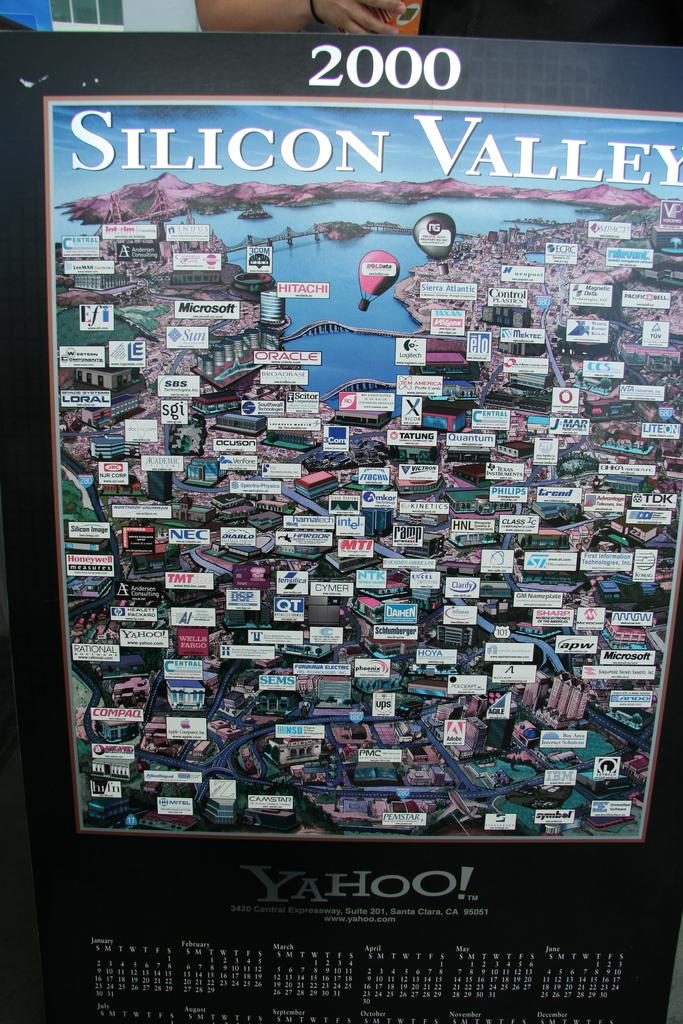<image>
Summarize the visual content of the image. A 2000 yahoo poster with a calendar on it. 